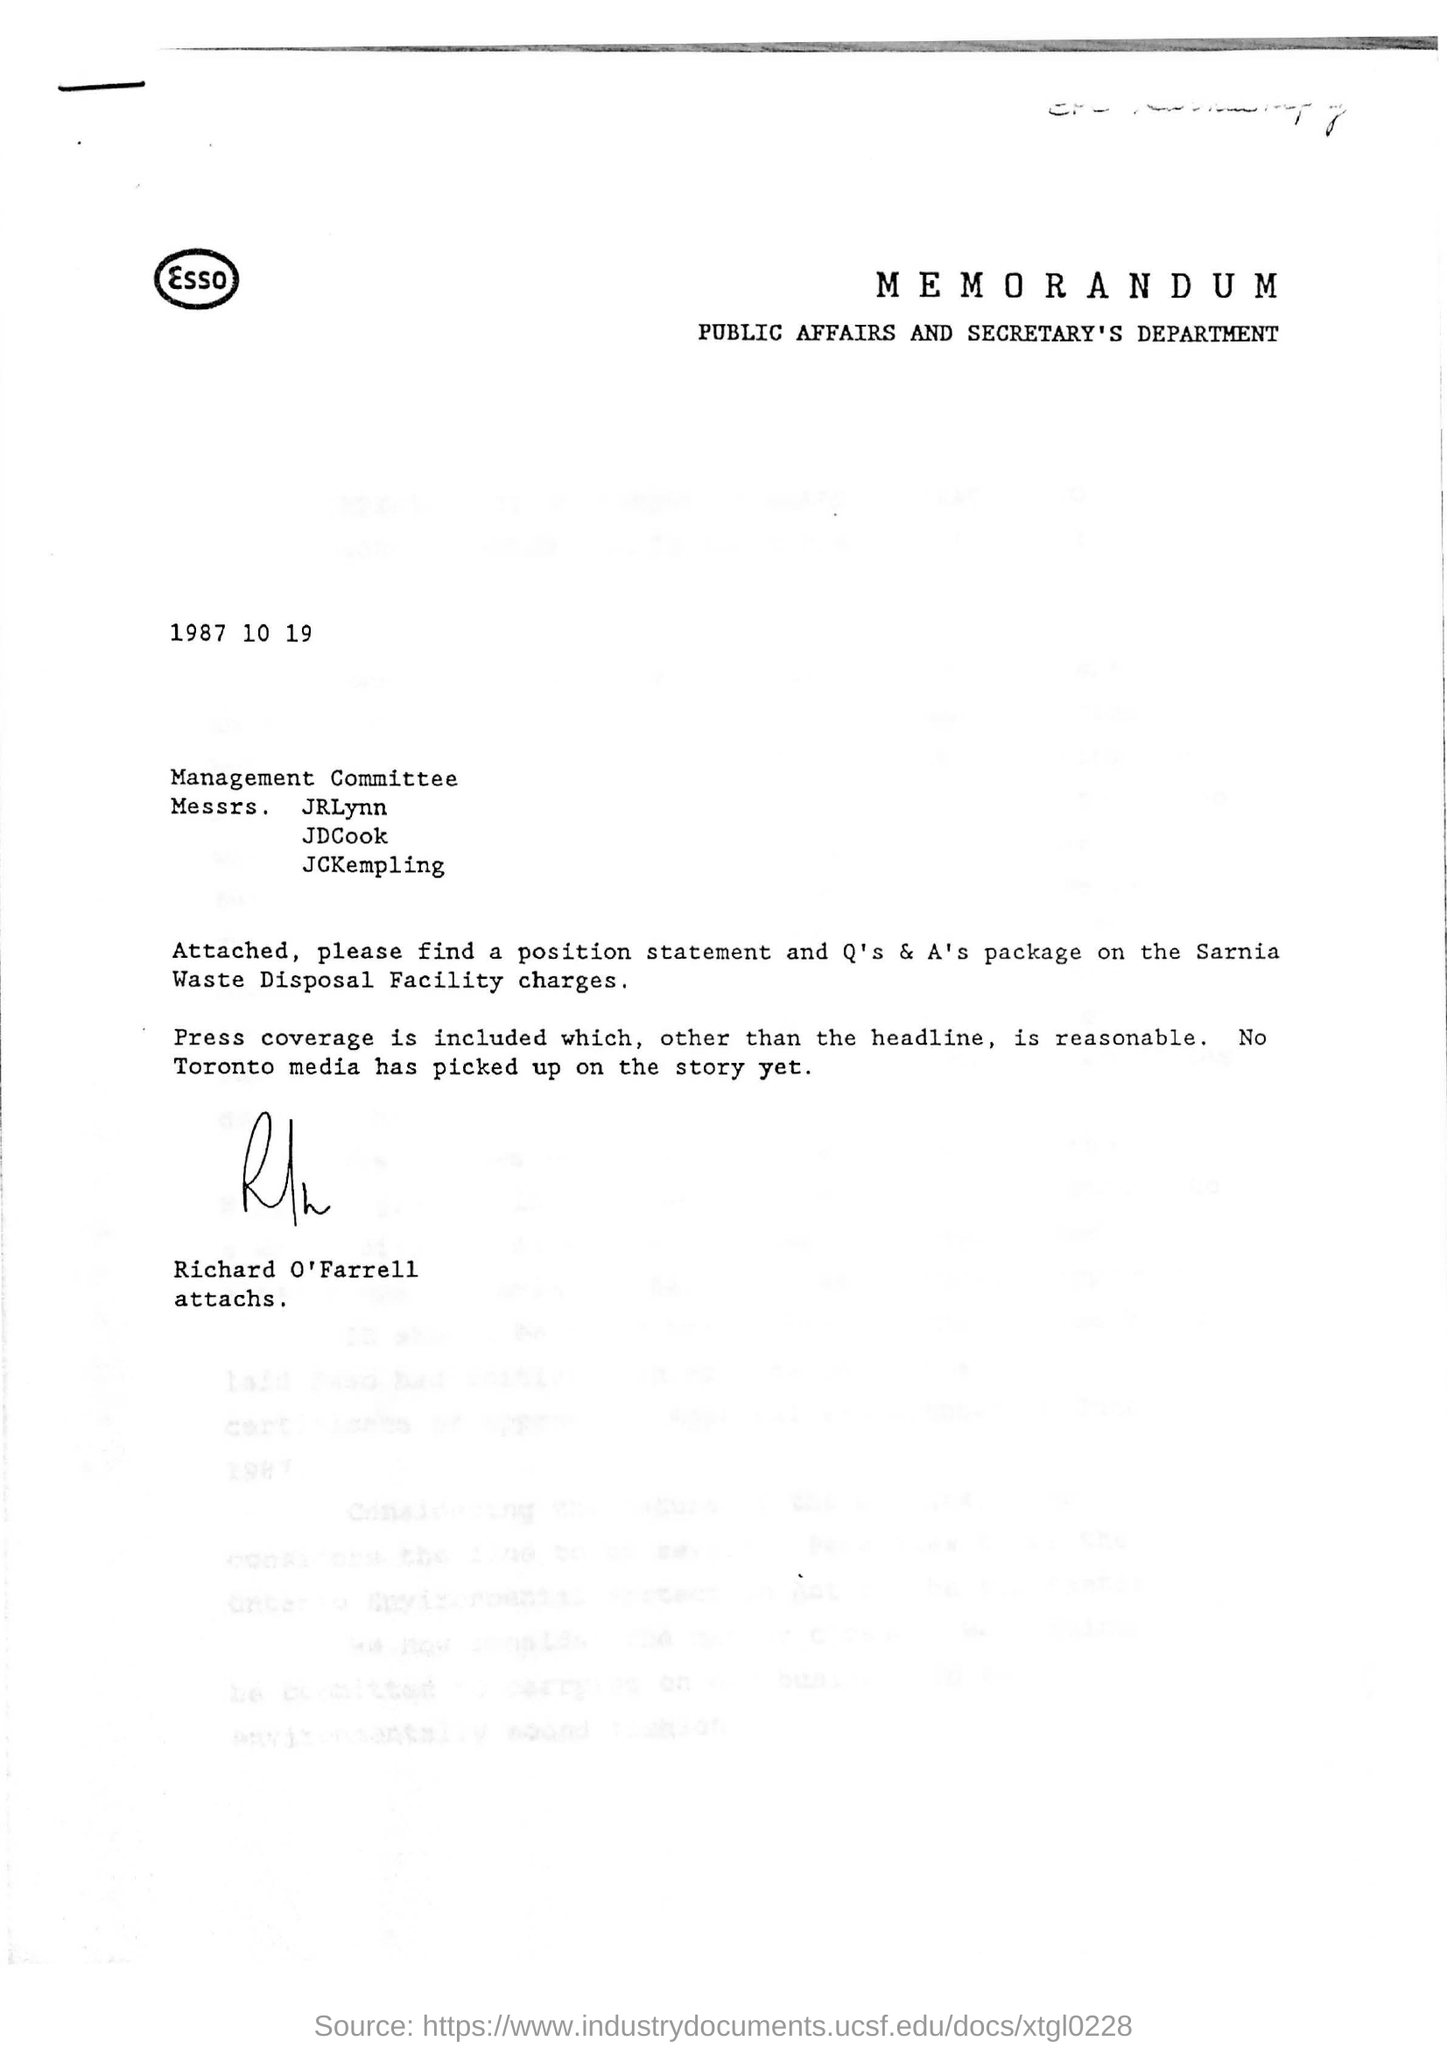Who has signed the letter?
Your answer should be very brief. Richard O'Farrell. Which department is mentioned?
Make the answer very short. PUBLIC AFFAIRS AND SECRETARY'S DEPARTMENT. 